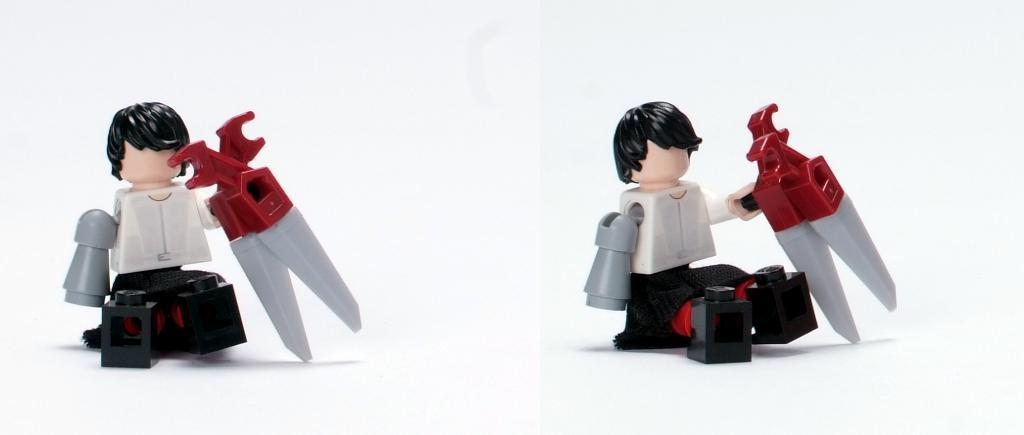What is the composition of the image? The image is a collage of two different images. What objects can be seen in the image? There are two toys in the image in the image. Can you describe the toys in the image? The toys are of similar type. Reasoning: Let' Let's think step by step in order to produce the conversation. We start by identifying the composition of the image, which is a collage of two different images. Then, we focus on the objects in the image, which are two toys. Finally, we describe the toys in more detail, noting that they are of similar type. Absurd Question/Answer: What type of machine is used to create the poison in the image? There is no machine or poison present in the image; it features a collage of two different images with two similar toys. 